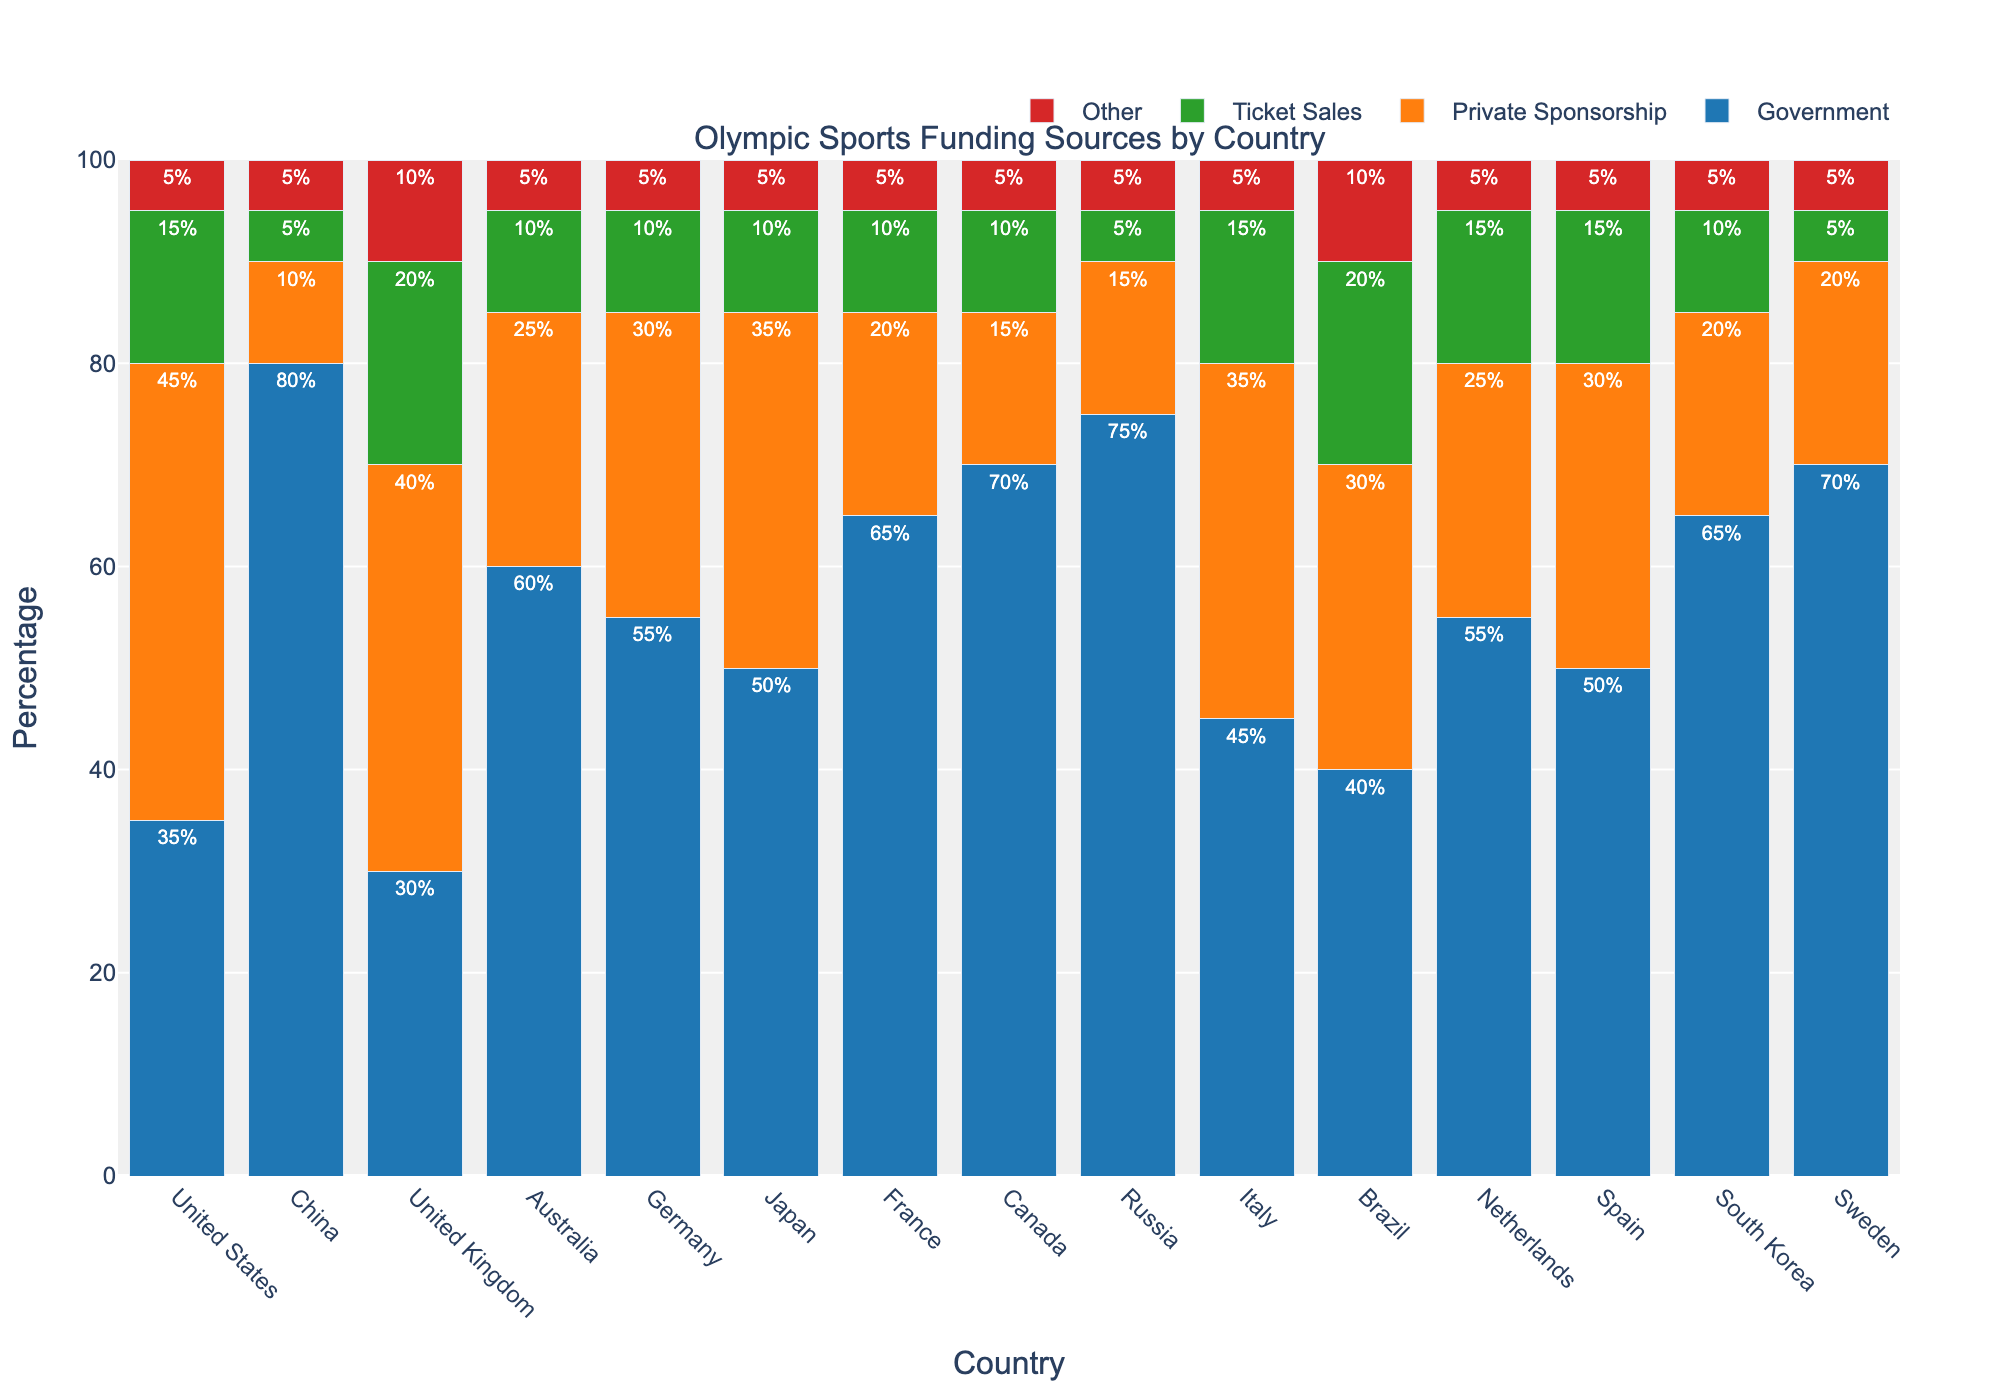Which country’s funding from the government and private sponsorship combined exceeds 70%? To find the answer, look for the country where the sum of the percentage values of government funding and private sponsorship is greater than 70%. The United States has 35% government and 45% private sponsorship, which sums up to 80%, exceeding 70%.
Answer: United States Which country has the lowest percentage of ticket sales? Look for the country with the smallest bar representing ticket sales. Both China and Russia have 5% of their funding from ticket sales, which is the lowest.
Answer: China, Russia Compared to Japan, which countries have a higher percentage of government funding? Japan has 50% government funding. Look for countries with a government funding percentage higher than 50%. China (80%), Australia (60%), Germany (55%), France (65%), Canada (70%), Russia (75%), South Korea (65%), and Sweden (70%) all have higher government funding than Japan.
Answer: China, Australia, Germany, France, Canada, Russia, South Korea, Sweden What is the difference in the percentage of private sponsorship between Brazil and France? Brazil has 30% private sponsorship, and France has 20%. The difference is 30% - 20% = 10%.
Answer: 10% Which countries have a combined government and ticket sales funding percentage of exactly 60%? Calculate the sum of government and ticket sales funding for each country. For Spain, it is 50% (government) + 15% (ticket sales) = 65%, which is the closest but not exactly 60%. There are no countries with an exact 60% sum.
Answer: None Which funding source has the most uniform distribution across all countries? Observe the variation in the heights of the bars representing each funding source across all countries. 'Other' seems to have the most uniform distribution as it consistently shows 5% across all countries.
Answer: Other What is the average percentage of private sponsorship across all the countries? Sum up the percentages of private sponsorship for all countries and divide by the number of countries. Total = 45 + 10 + 40 + 25 + 30 + 35 + 20 + 15 + 15 + 35 + 30 + 25 + 30 + 20 + 20 = 395. Number of countries = 15. Average = 395/15 ≈ 26.33%.
Answer: 26.33% Which country has the highest percentage of funding from the source labeled 'Other'? Observe the heights of the bars labeled 'Other' for each country. 'Other' is consistently 5% for all countries, so no country has a percentage higher than the others.
Answer: All countries equally Which country relies the most on government funding for its Olympic sports? Look for the country with the tallest bar representing government funding. China has the highest government funding percentage at 80%.
Answer: China 